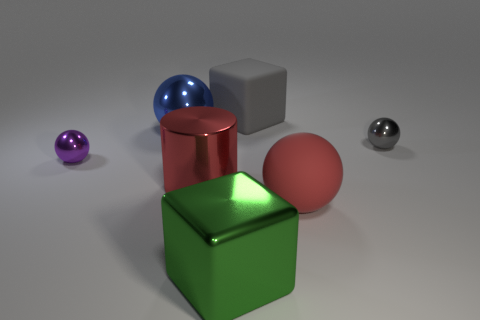Subtract all tiny gray balls. How many balls are left? 3 Add 1 small blue things. How many objects exist? 8 Subtract all red spheres. How many spheres are left? 3 Subtract 1 cubes. How many cubes are left? 1 Add 5 small blue spheres. How many small blue spheres exist? 5 Subtract 1 purple balls. How many objects are left? 6 Subtract all blocks. How many objects are left? 5 Subtract all green cylinders. Subtract all gray balls. How many cylinders are left? 1 Subtract all tiny balls. Subtract all gray matte blocks. How many objects are left? 4 Add 7 green shiny blocks. How many green shiny blocks are left? 8 